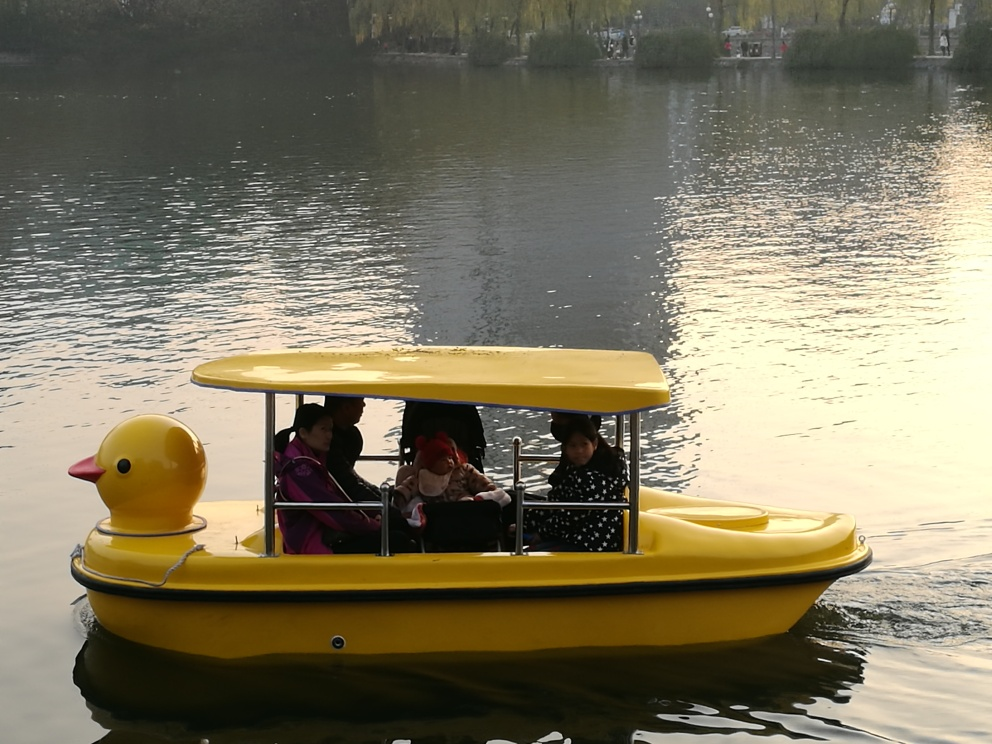What elements in this image suggest it might be a calm and peaceful setting? The placid water reflecting the gentle light, along with the leisurely pace of the duck-shaped boat carrying relaxed passengers, evokes a sense of tranquility and peacefulness in the setting. 